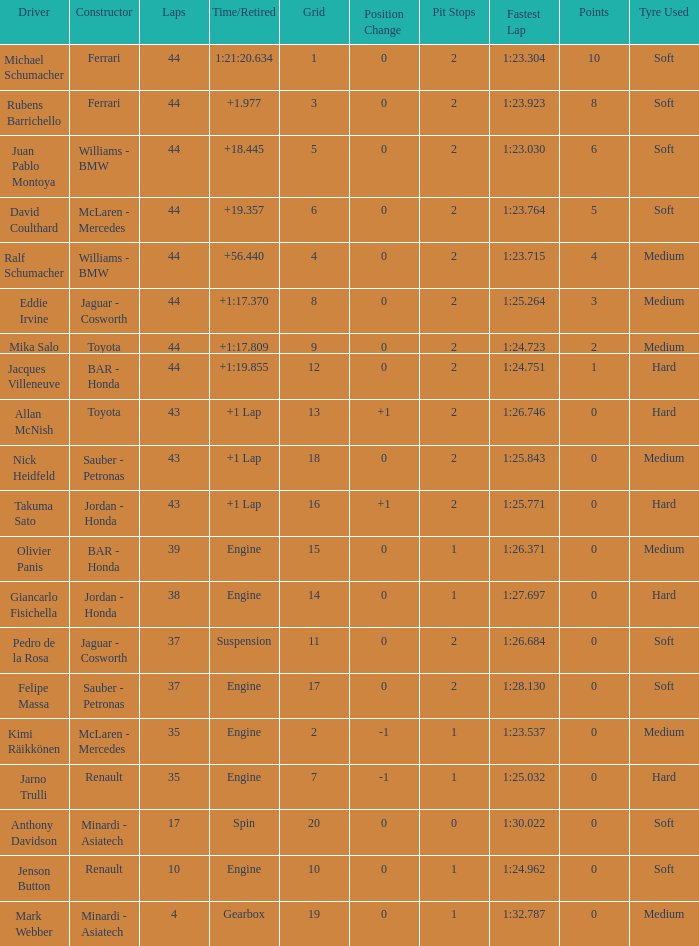What was the fewest laps for somone who finished +18.445? 44.0. 